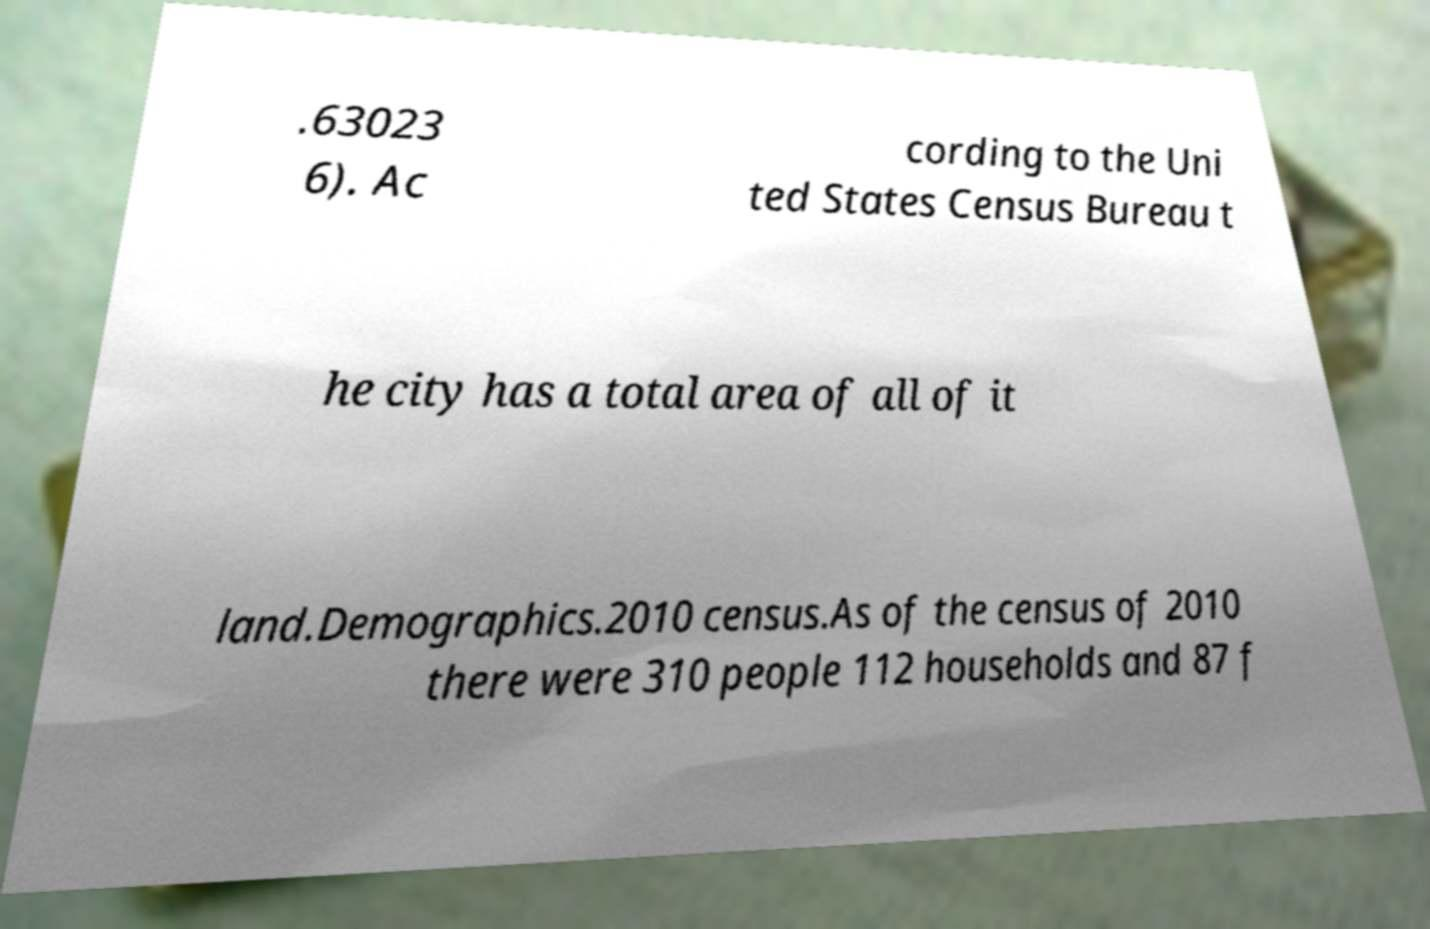I need the written content from this picture converted into text. Can you do that? .63023 6). Ac cording to the Uni ted States Census Bureau t he city has a total area of all of it land.Demographics.2010 census.As of the census of 2010 there were 310 people 112 households and 87 f 